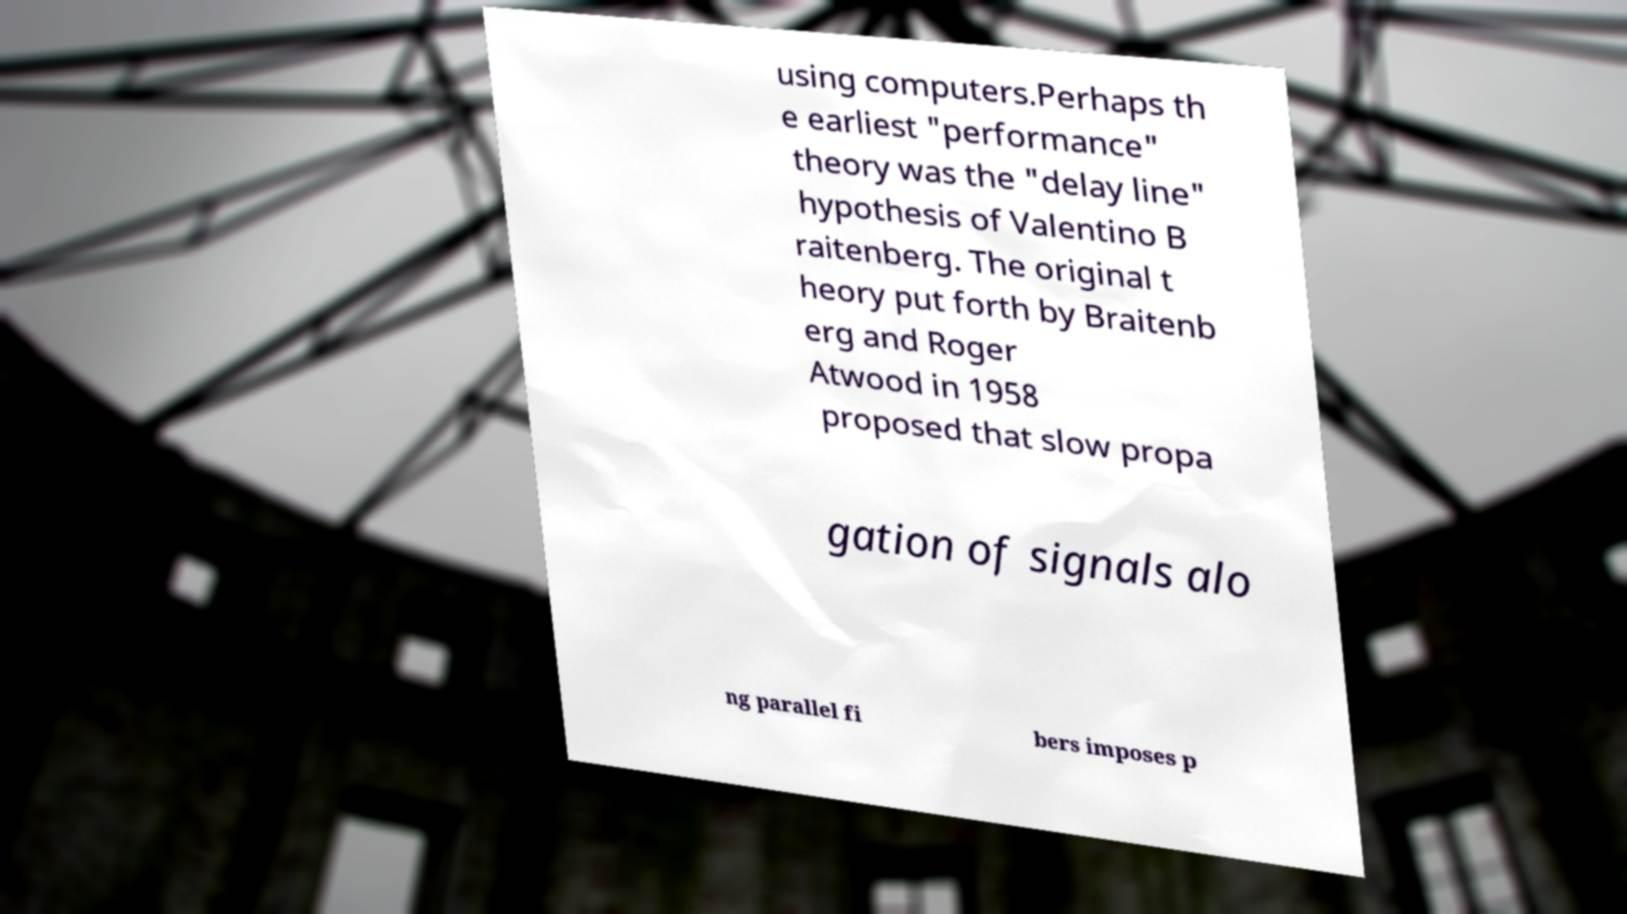Can you read and provide the text displayed in the image?This photo seems to have some interesting text. Can you extract and type it out for me? using computers.Perhaps th e earliest "performance" theory was the "delay line" hypothesis of Valentino B raitenberg. The original t heory put forth by Braitenb erg and Roger Atwood in 1958 proposed that slow propa gation of signals alo ng parallel fi bers imposes p 